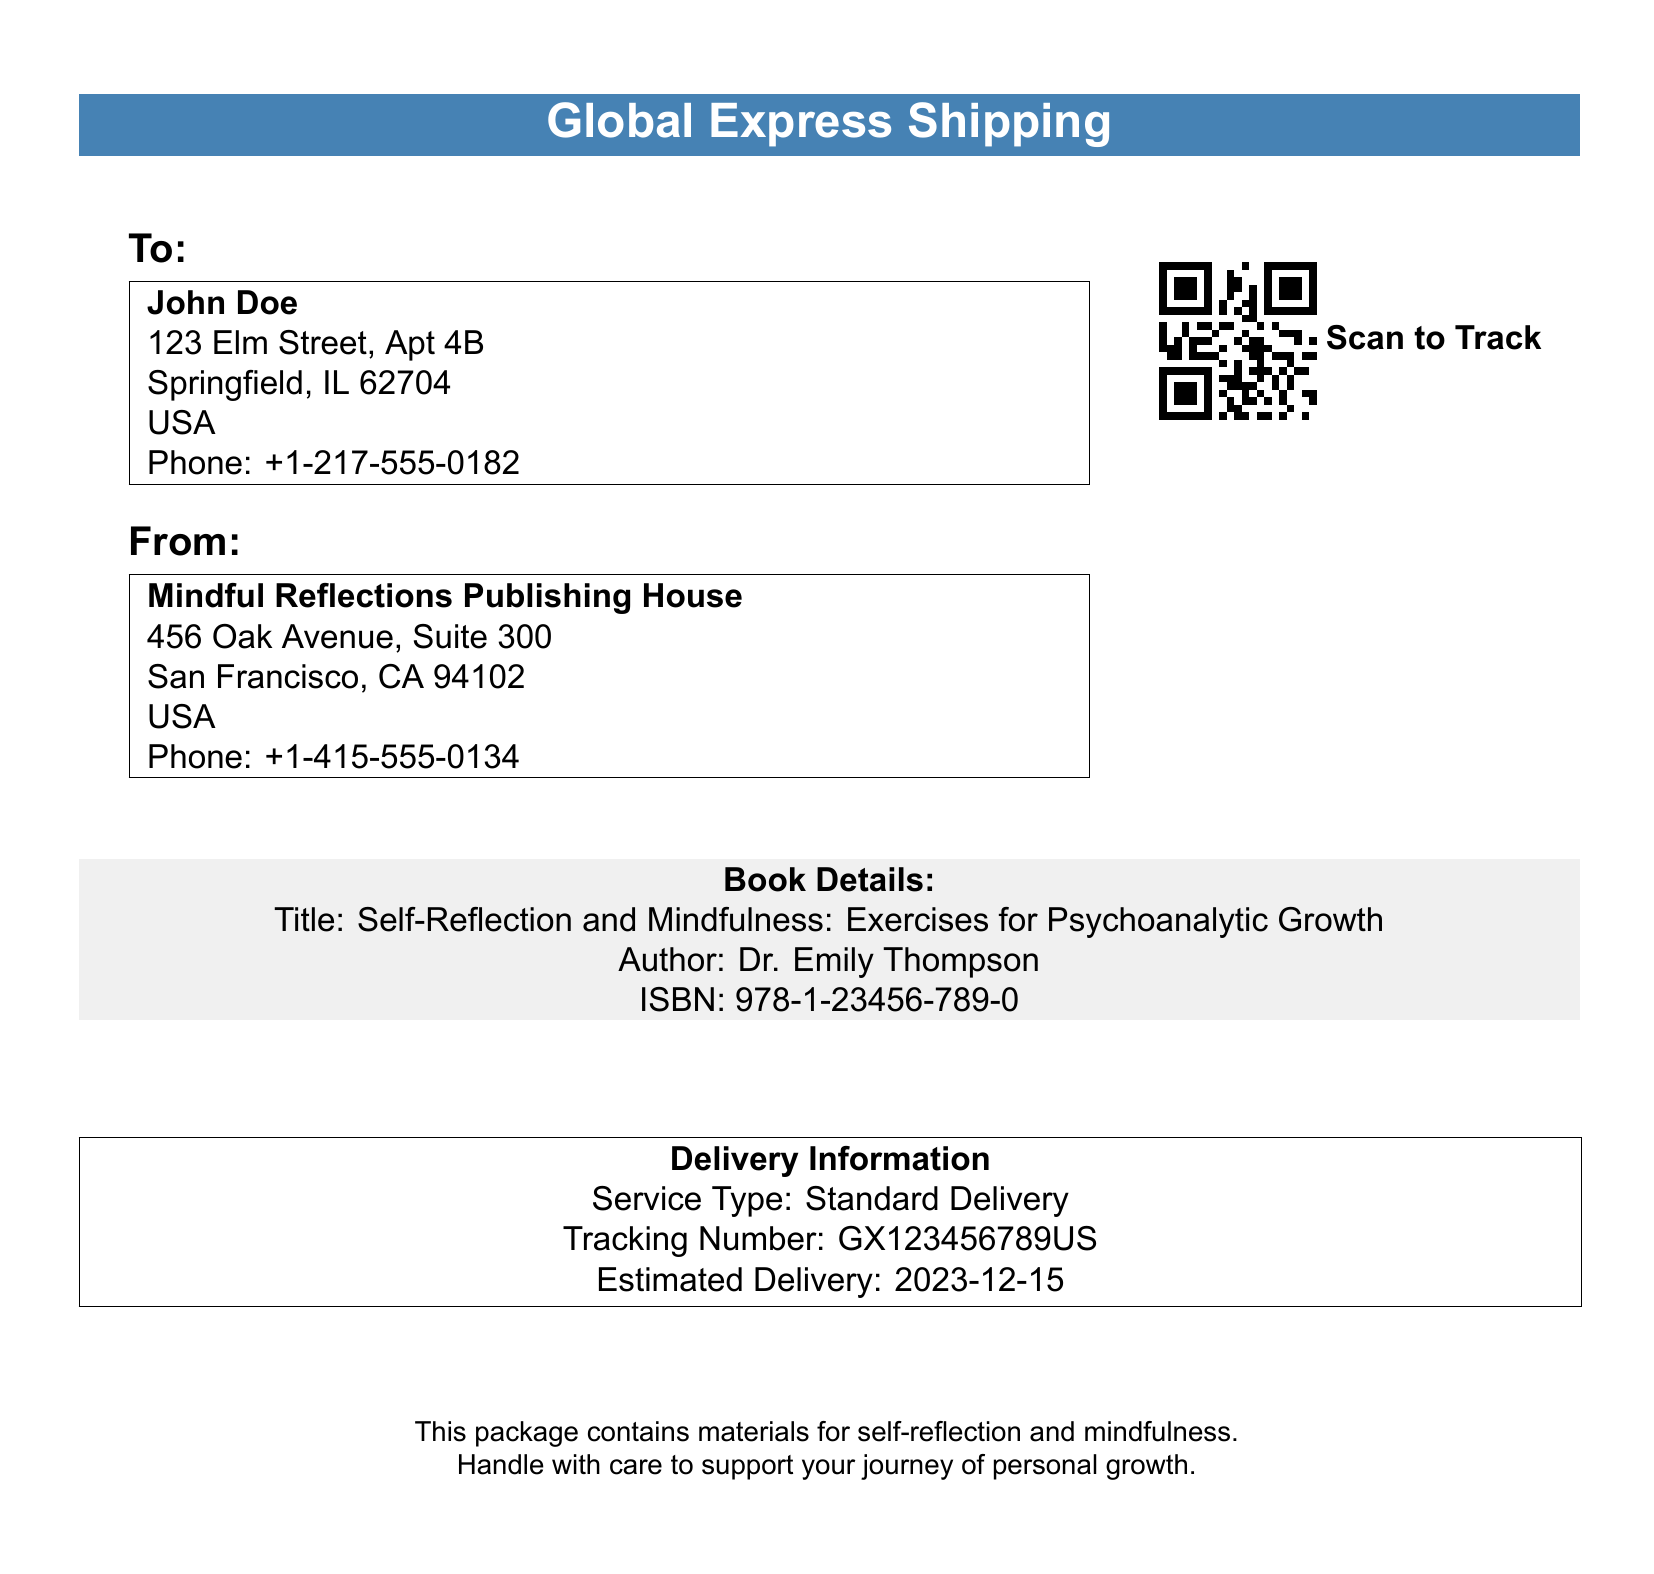What is the recipient's name? The recipient's name is found in the "To" section of the document, which lists "John Doe."
Answer: John Doe What is the sender's phone number? The sender's phone number is mentioned in the "From" section of the document as "+1-415-555-0134."
Answer: +1-415-555-0134 What is the estimated delivery date? The estimated delivery date is specified in the "Delivery Information" section of the document as "2023-12-15."
Answer: 2023-12-15 What is the title of the book included in the package? The title of the book is detailed in the "Book Details" section as "Self-Reflection and Mindfulness: Exercises for Psychoanalytic Growth."
Answer: Self-Reflection and Mindfulness: Exercises for Psychoanalytic Growth What service type is used for delivery? The service type for delivery is specified in the "Delivery Information" section as "Standard Delivery."
Answer: Standard Delivery How many different phone numbers are provided in the document? The document contains two phone numbers, one for the recipient and one for the sender.
Answer: 2 What is the tracking number for this shipment? The tracking number is listed in the "Delivery Information" section as "GX123456789US."
Answer: GX123456789US Who is the author of the book? The author's name is provided in the "Book Details" section as "Dr. Emily Thompson."
Answer: Dr. Emily Thompson 